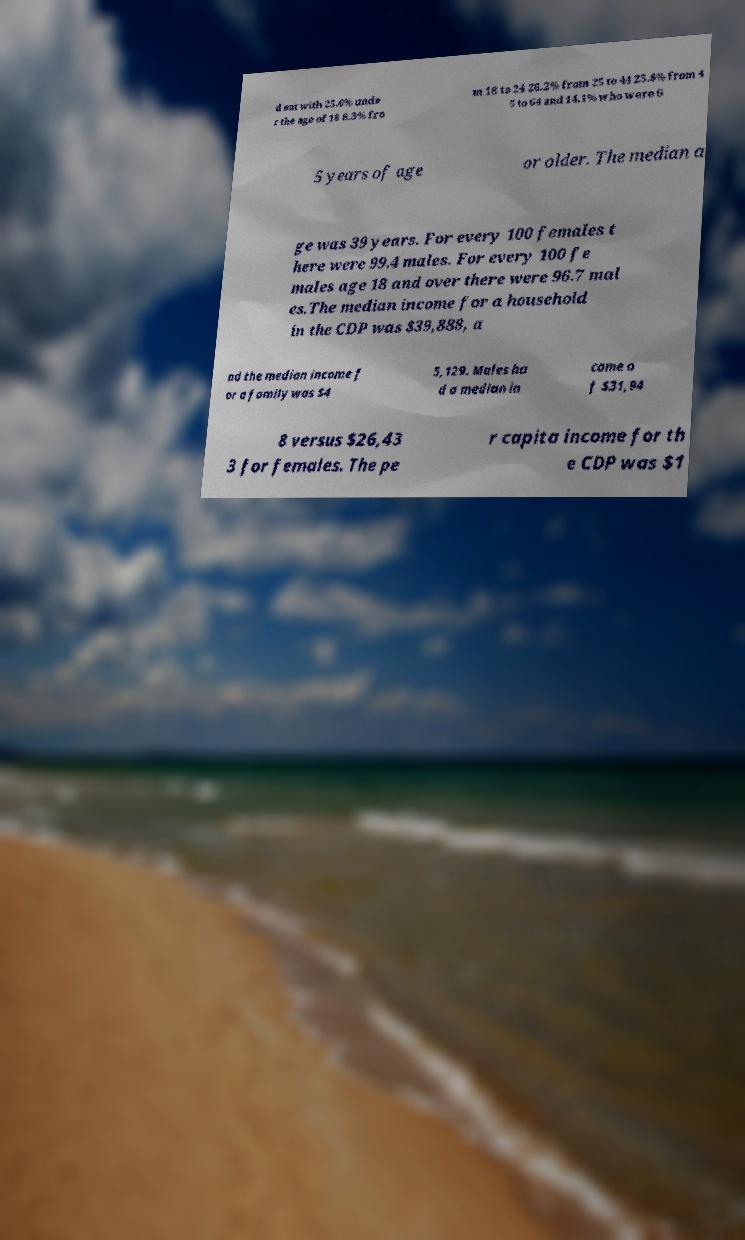Can you read and provide the text displayed in the image?This photo seems to have some interesting text. Can you extract and type it out for me? d out with 25.6% unde r the age of 18 8.3% fro m 18 to 24 26.2% from 25 to 44 25.8% from 4 5 to 64 and 14.1% who were 6 5 years of age or older. The median a ge was 39 years. For every 100 females t here were 99.4 males. For every 100 fe males age 18 and over there were 96.7 mal es.The median income for a household in the CDP was $39,888, a nd the median income f or a family was $4 5,129. Males ha d a median in come o f $31,94 8 versus $26,43 3 for females. The pe r capita income for th e CDP was $1 